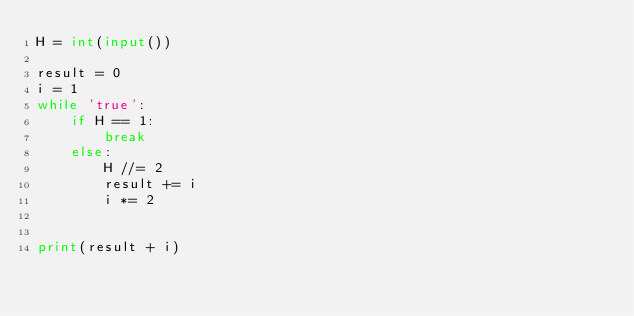<code> <loc_0><loc_0><loc_500><loc_500><_Python_>H = int(input())

result = 0
i = 1
while 'true':
    if H == 1:
        break
    else:
        H //= 2
        result += i
        i *= 2
        
        
print(result + i)

</code> 